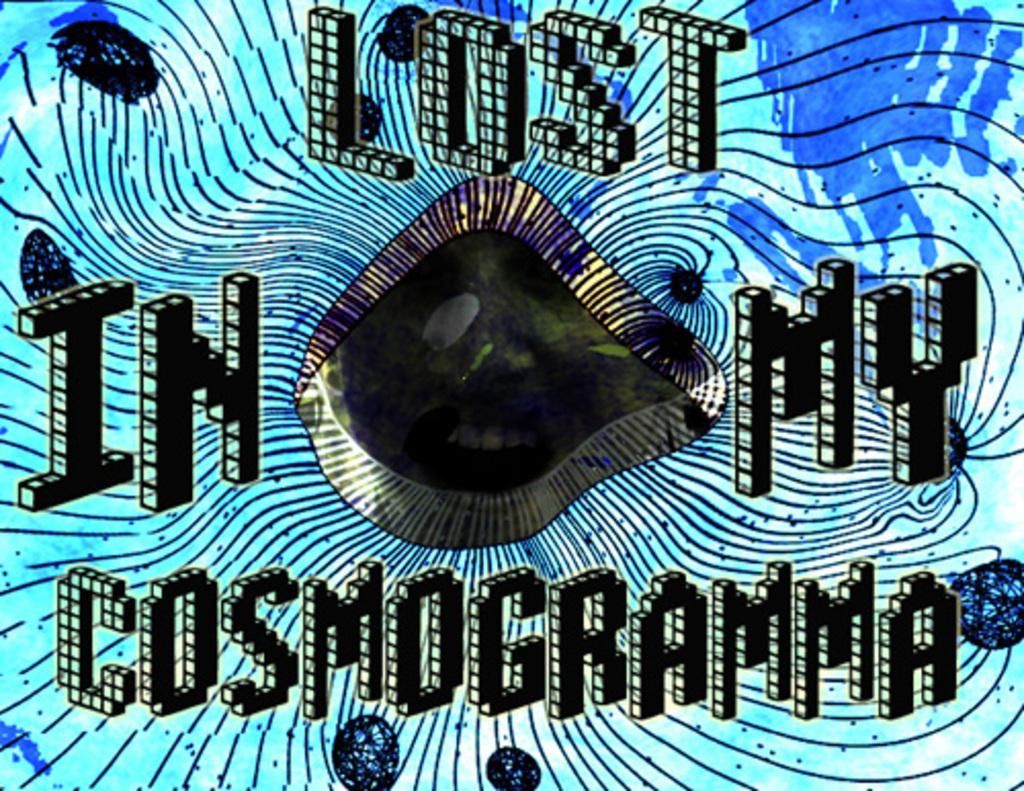<image>
Share a concise interpretation of the image provided. A blue poster titled LOST IN MY COSMOGRAMMA. 